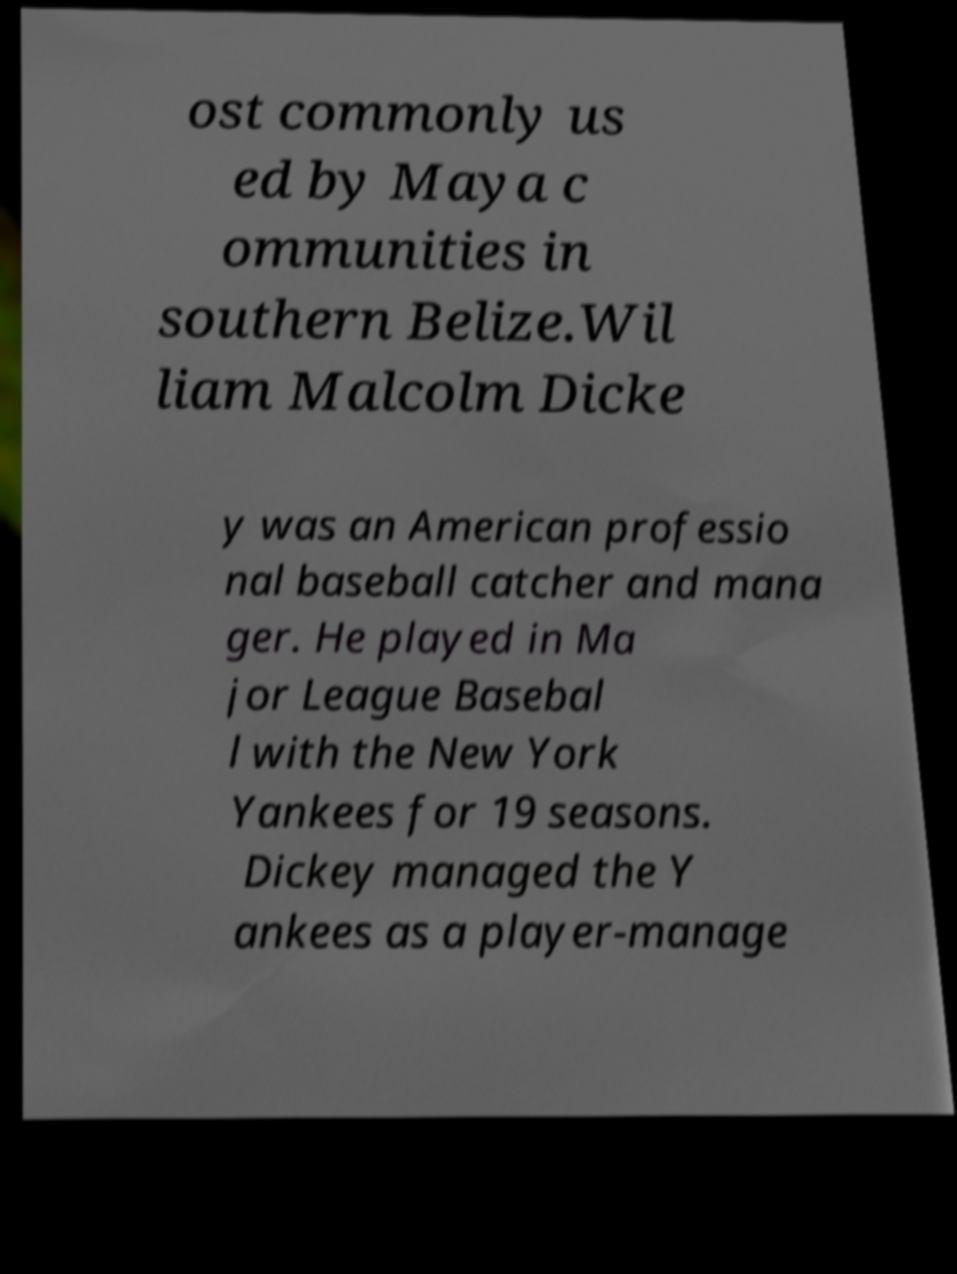What messages or text are displayed in this image? I need them in a readable, typed format. ost commonly us ed by Maya c ommunities in southern Belize.Wil liam Malcolm Dicke y was an American professio nal baseball catcher and mana ger. He played in Ma jor League Basebal l with the New York Yankees for 19 seasons. Dickey managed the Y ankees as a player-manage 